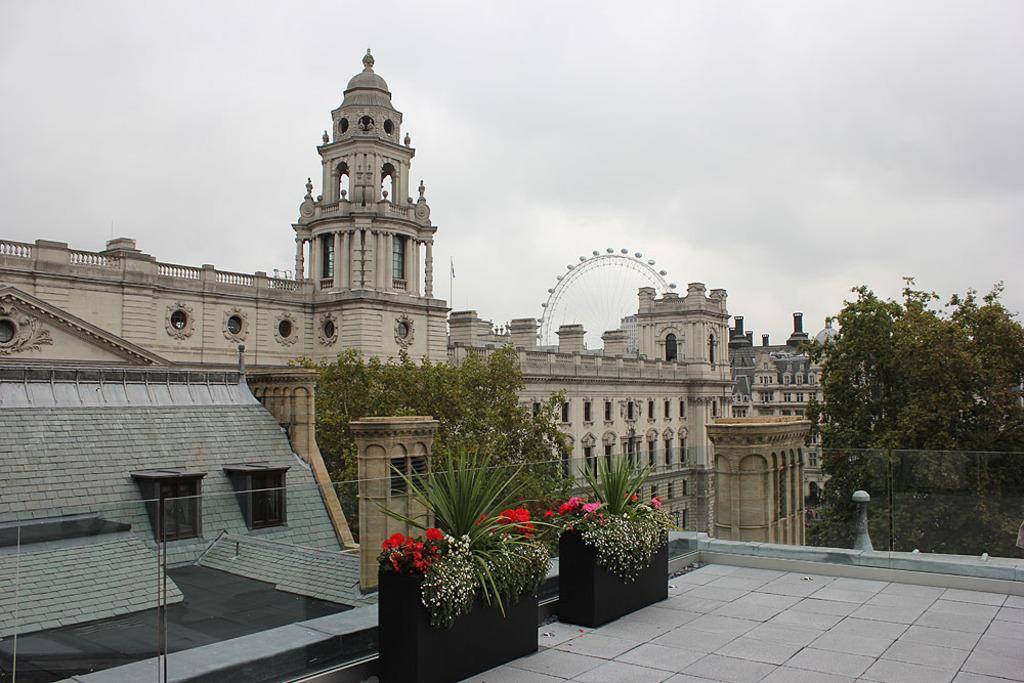Could you give a brief overview of what you see in this image? In this image there are buildings and trees, in front of the building there are flowers and plants, in the background of the image there is a giant wall. 